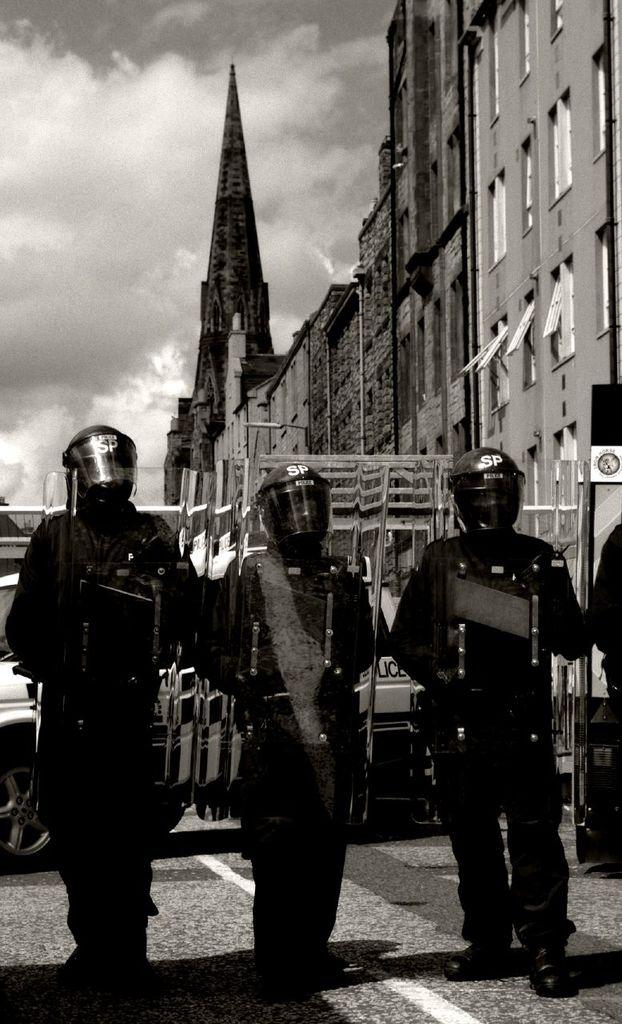How many people are in the image? There is a group of people in the image. What are the people wearing on their heads? The people are wearing helmets. What can be seen on the road in the image? There is a vehicle visible on the road in the image. What is visible in the background of the image? There are buildings in the background of the image. What is visible in the sky in the image? Clouds are present in the sky in the image. What color is the crayon being used by the people in the image? There is no crayon present in the image; the people are wearing helmets. How many sidewalks can be seen in the image? There is no mention of a sidewalk in the image; it features a group of people, a vehicle, buildings, and clouds. 